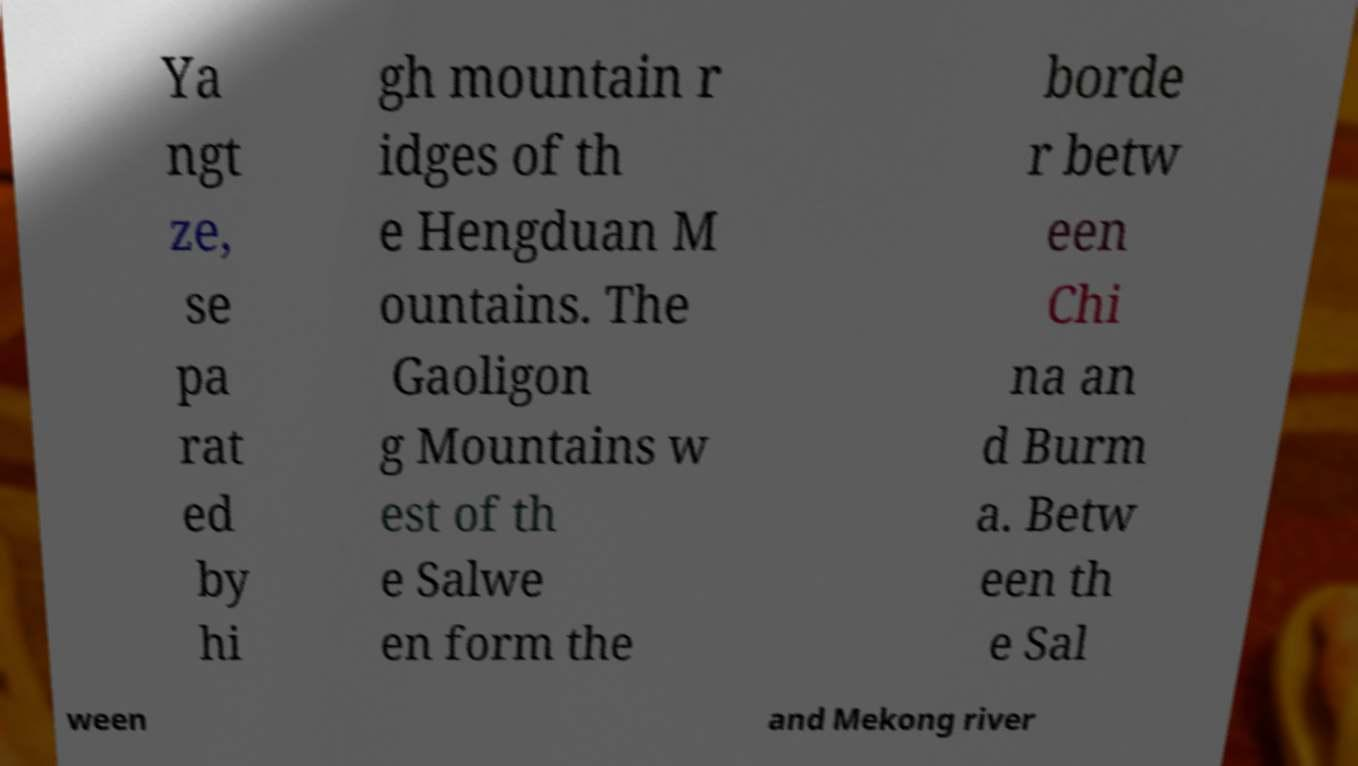What messages or text are displayed in this image? I need them in a readable, typed format. Ya ngt ze, se pa rat ed by hi gh mountain r idges of th e Hengduan M ountains. The Gaoligon g Mountains w est of th e Salwe en form the borde r betw een Chi na an d Burm a. Betw een th e Sal ween and Mekong river 